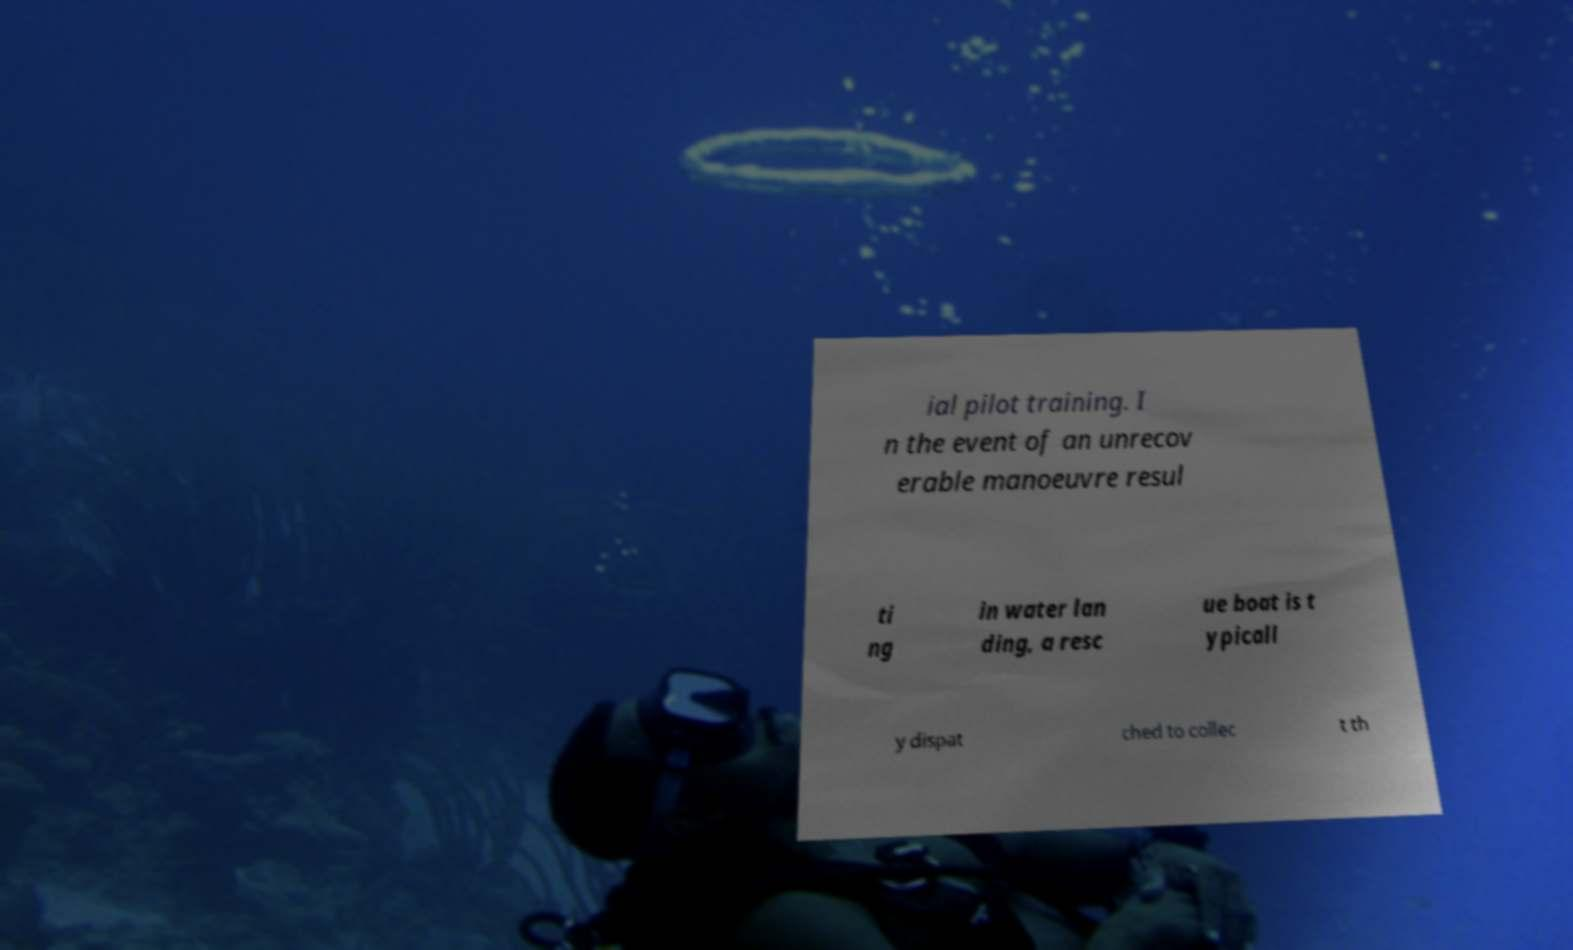What messages or text are displayed in this image? I need them in a readable, typed format. ial pilot training. I n the event of an unrecov erable manoeuvre resul ti ng in water lan ding, a resc ue boat is t ypicall y dispat ched to collec t th 